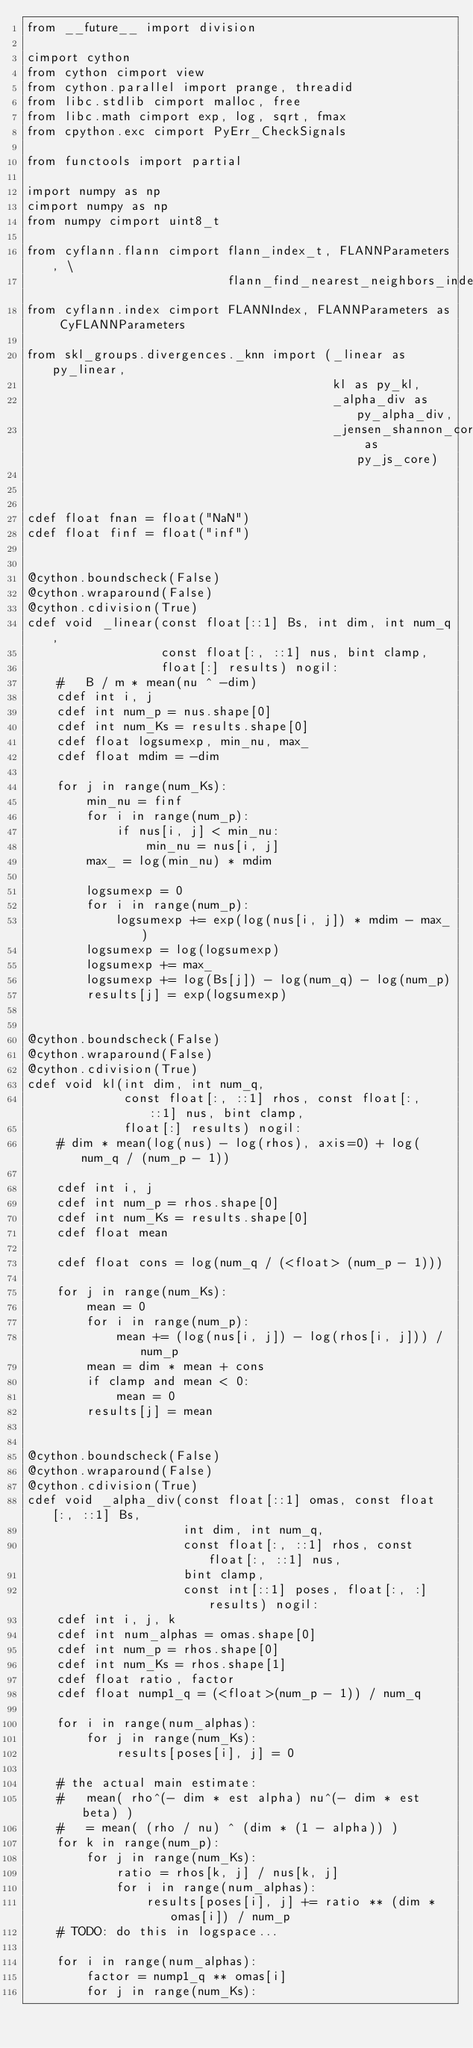<code> <loc_0><loc_0><loc_500><loc_500><_Cython_>from __future__ import division

cimport cython
from cython cimport view
from cython.parallel import prange, threadid
from libc.stdlib cimport malloc, free
from libc.math cimport exp, log, sqrt, fmax
from cpython.exc cimport PyErr_CheckSignals

from functools import partial

import numpy as np
cimport numpy as np
from numpy cimport uint8_t

from cyflann.flann cimport flann_index_t, FLANNParameters, \
                           flann_find_nearest_neighbors_index_float
from cyflann.index cimport FLANNIndex, FLANNParameters as CyFLANNParameters

from skl_groups.divergences._knn import (_linear as py_linear,
                                         kl as py_kl,
                                         _alpha_div as py_alpha_div,
                                         _jensen_shannon_core as py_js_core)



cdef float fnan = float("NaN")
cdef float finf = float("inf")


@cython.boundscheck(False)
@cython.wraparound(False)
@cython.cdivision(True)
cdef void _linear(const float[::1] Bs, int dim, int num_q,
                  const float[:, ::1] nus, bint clamp,
                  float[:] results) nogil:
    #   B / m * mean(nu ^ -dim)
    cdef int i, j
    cdef int num_p = nus.shape[0]
    cdef int num_Ks = results.shape[0]
    cdef float logsumexp, min_nu, max_
    cdef float mdim = -dim

    for j in range(num_Ks):
        min_nu = finf
        for i in range(num_p):
            if nus[i, j] < min_nu:
                min_nu = nus[i, j]
        max_ = log(min_nu) * mdim

        logsumexp = 0
        for i in range(num_p):
            logsumexp += exp(log(nus[i, j]) * mdim - max_)
        logsumexp = log(logsumexp)
        logsumexp += max_
        logsumexp += log(Bs[j]) - log(num_q) - log(num_p)
        results[j] = exp(logsumexp)


@cython.boundscheck(False)
@cython.wraparound(False)
@cython.cdivision(True)
cdef void kl(int dim, int num_q,
             const float[:, ::1] rhos, const float[:, ::1] nus, bint clamp,
             float[:] results) nogil:
    # dim * mean(log(nus) - log(rhos), axis=0) + log(num_q / (num_p - 1))

    cdef int i, j
    cdef int num_p = rhos.shape[0]
    cdef int num_Ks = results.shape[0]
    cdef float mean

    cdef float cons = log(num_q / (<float> (num_p - 1)))

    for j in range(num_Ks):
        mean = 0
        for i in range(num_p):
            mean += (log(nus[i, j]) - log(rhos[i, j])) / num_p
        mean = dim * mean + cons
        if clamp and mean < 0:
            mean = 0
        results[j] = mean


@cython.boundscheck(False)
@cython.wraparound(False)
@cython.cdivision(True)
cdef void _alpha_div(const float[::1] omas, const float[:, ::1] Bs,
                     int dim, int num_q,
                     const float[:, ::1] rhos, const float[:, ::1] nus,
                     bint clamp,
                     const int[::1] poses, float[:, :] results) nogil:
    cdef int i, j, k
    cdef int num_alphas = omas.shape[0]
    cdef int num_p = rhos.shape[0]
    cdef int num_Ks = rhos.shape[1]
    cdef float ratio, factor
    cdef float nump1_q = (<float>(num_p - 1)) / num_q

    for i in range(num_alphas):
        for j in range(num_Ks):
            results[poses[i], j] = 0

    # the actual main estimate:
    #   mean( rho^(- dim * est alpha) nu^(- dim * est beta) )
    #   = mean( (rho / nu) ^ (dim * (1 - alpha)) )
    for k in range(num_p):
        for j in range(num_Ks):
            ratio = rhos[k, j] / nus[k, j]
            for i in range(num_alphas):
                results[poses[i], j] += ratio ** (dim * omas[i]) / num_p
    # TODO: do this in logspace...

    for i in range(num_alphas):
        factor = nump1_q ** omas[i]
        for j in range(num_Ks):</code> 